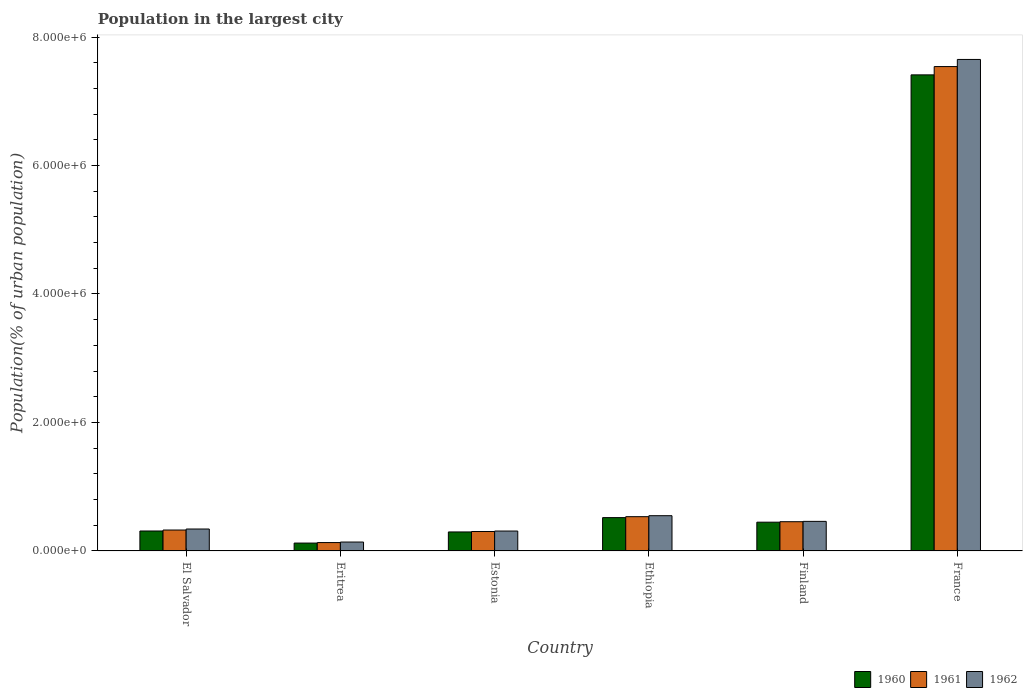How many different coloured bars are there?
Offer a terse response. 3. How many groups of bars are there?
Provide a succinct answer. 6. How many bars are there on the 3rd tick from the left?
Provide a short and direct response. 3. What is the label of the 5th group of bars from the left?
Make the answer very short. Finland. What is the population in the largest city in 1960 in Finland?
Make the answer very short. 4.48e+05. Across all countries, what is the maximum population in the largest city in 1960?
Give a very brief answer. 7.41e+06. Across all countries, what is the minimum population in the largest city in 1962?
Provide a succinct answer. 1.39e+05. In which country was the population in the largest city in 1960 maximum?
Keep it short and to the point. France. In which country was the population in the largest city in 1961 minimum?
Your response must be concise. Eritrea. What is the total population in the largest city in 1962 in the graph?
Give a very brief answer. 9.45e+06. What is the difference between the population in the largest city in 1960 in Ethiopia and that in Finland?
Your response must be concise. 7.10e+04. What is the difference between the population in the largest city in 1962 in France and the population in the largest city in 1960 in Finland?
Provide a short and direct response. 7.20e+06. What is the average population in the largest city in 1960 per country?
Provide a succinct answer. 1.52e+06. What is the difference between the population in the largest city of/in 1961 and population in the largest city of/in 1962 in El Salvador?
Your answer should be very brief. -1.58e+04. What is the ratio of the population in the largest city in 1961 in El Salvador to that in Ethiopia?
Your answer should be compact. 0.61. Is the difference between the population in the largest city in 1961 in Finland and France greater than the difference between the population in the largest city in 1962 in Finland and France?
Ensure brevity in your answer.  Yes. What is the difference between the highest and the second highest population in the largest city in 1962?
Provide a short and direct response. 8.82e+04. What is the difference between the highest and the lowest population in the largest city in 1962?
Offer a very short reply. 7.51e+06. Is the sum of the population in the largest city in 1960 in Ethiopia and France greater than the maximum population in the largest city in 1962 across all countries?
Give a very brief answer. Yes. What does the 2nd bar from the left in Estonia represents?
Give a very brief answer. 1961. What does the 1st bar from the right in Estonia represents?
Provide a succinct answer. 1962. Is it the case that in every country, the sum of the population in the largest city in 1961 and population in the largest city in 1960 is greater than the population in the largest city in 1962?
Provide a succinct answer. Yes. Are the values on the major ticks of Y-axis written in scientific E-notation?
Ensure brevity in your answer.  Yes. Does the graph contain any zero values?
Give a very brief answer. No. How are the legend labels stacked?
Provide a succinct answer. Horizontal. What is the title of the graph?
Your response must be concise. Population in the largest city. What is the label or title of the Y-axis?
Keep it short and to the point. Population(% of urban population). What is the Population(% of urban population) of 1960 in El Salvador?
Make the answer very short. 3.11e+05. What is the Population(% of urban population) of 1961 in El Salvador?
Your answer should be compact. 3.26e+05. What is the Population(% of urban population) in 1962 in El Salvador?
Offer a terse response. 3.42e+05. What is the Population(% of urban population) in 1960 in Eritrea?
Your answer should be very brief. 1.23e+05. What is the Population(% of urban population) of 1961 in Eritrea?
Keep it short and to the point. 1.31e+05. What is the Population(% of urban population) in 1962 in Eritrea?
Offer a terse response. 1.39e+05. What is the Population(% of urban population) of 1960 in Estonia?
Make the answer very short. 2.96e+05. What is the Population(% of urban population) in 1961 in Estonia?
Offer a terse response. 3.03e+05. What is the Population(% of urban population) of 1962 in Estonia?
Make the answer very short. 3.10e+05. What is the Population(% of urban population) in 1960 in Ethiopia?
Offer a terse response. 5.19e+05. What is the Population(% of urban population) in 1961 in Ethiopia?
Your response must be concise. 5.34e+05. What is the Population(% of urban population) of 1962 in Ethiopia?
Your response must be concise. 5.49e+05. What is the Population(% of urban population) in 1960 in Finland?
Ensure brevity in your answer.  4.48e+05. What is the Population(% of urban population) in 1961 in Finland?
Provide a succinct answer. 4.55e+05. What is the Population(% of urban population) in 1962 in Finland?
Provide a short and direct response. 4.61e+05. What is the Population(% of urban population) in 1960 in France?
Offer a very short reply. 7.41e+06. What is the Population(% of urban population) of 1961 in France?
Offer a very short reply. 7.54e+06. What is the Population(% of urban population) of 1962 in France?
Offer a terse response. 7.65e+06. Across all countries, what is the maximum Population(% of urban population) in 1960?
Provide a succinct answer. 7.41e+06. Across all countries, what is the maximum Population(% of urban population) of 1961?
Give a very brief answer. 7.54e+06. Across all countries, what is the maximum Population(% of urban population) in 1962?
Ensure brevity in your answer.  7.65e+06. Across all countries, what is the minimum Population(% of urban population) in 1960?
Provide a succinct answer. 1.23e+05. Across all countries, what is the minimum Population(% of urban population) of 1961?
Your answer should be very brief. 1.31e+05. Across all countries, what is the minimum Population(% of urban population) of 1962?
Provide a short and direct response. 1.39e+05. What is the total Population(% of urban population) of 1960 in the graph?
Keep it short and to the point. 9.11e+06. What is the total Population(% of urban population) of 1961 in the graph?
Your answer should be compact. 9.29e+06. What is the total Population(% of urban population) of 1962 in the graph?
Provide a succinct answer. 9.45e+06. What is the difference between the Population(% of urban population) of 1960 in El Salvador and that in Eritrea?
Your answer should be compact. 1.88e+05. What is the difference between the Population(% of urban population) in 1961 in El Salvador and that in Eritrea?
Your response must be concise. 1.95e+05. What is the difference between the Population(% of urban population) of 1962 in El Salvador and that in Eritrea?
Provide a short and direct response. 2.03e+05. What is the difference between the Population(% of urban population) of 1960 in El Salvador and that in Estonia?
Ensure brevity in your answer.  1.49e+04. What is the difference between the Population(% of urban population) in 1961 in El Salvador and that in Estonia?
Provide a succinct answer. 2.30e+04. What is the difference between the Population(% of urban population) in 1962 in El Salvador and that in Estonia?
Provide a short and direct response. 3.18e+04. What is the difference between the Population(% of urban population) of 1960 in El Salvador and that in Ethiopia?
Ensure brevity in your answer.  -2.08e+05. What is the difference between the Population(% of urban population) of 1961 in El Salvador and that in Ethiopia?
Provide a short and direct response. -2.08e+05. What is the difference between the Population(% of urban population) of 1962 in El Salvador and that in Ethiopia?
Offer a terse response. -2.07e+05. What is the difference between the Population(% of urban population) in 1960 in El Salvador and that in Finland?
Ensure brevity in your answer.  -1.37e+05. What is the difference between the Population(% of urban population) of 1961 in El Salvador and that in Finland?
Ensure brevity in your answer.  -1.29e+05. What is the difference between the Population(% of urban population) of 1962 in El Salvador and that in Finland?
Your answer should be compact. -1.19e+05. What is the difference between the Population(% of urban population) in 1960 in El Salvador and that in France?
Keep it short and to the point. -7.10e+06. What is the difference between the Population(% of urban population) in 1961 in El Salvador and that in France?
Provide a succinct answer. -7.21e+06. What is the difference between the Population(% of urban population) in 1962 in El Salvador and that in France?
Make the answer very short. -7.31e+06. What is the difference between the Population(% of urban population) of 1960 in Eritrea and that in Estonia?
Keep it short and to the point. -1.73e+05. What is the difference between the Population(% of urban population) of 1961 in Eritrea and that in Estonia?
Your answer should be very brief. -1.72e+05. What is the difference between the Population(% of urban population) of 1962 in Eritrea and that in Estonia?
Your response must be concise. -1.71e+05. What is the difference between the Population(% of urban population) in 1960 in Eritrea and that in Ethiopia?
Your response must be concise. -3.96e+05. What is the difference between the Population(% of urban population) in 1961 in Eritrea and that in Ethiopia?
Keep it short and to the point. -4.03e+05. What is the difference between the Population(% of urban population) of 1962 in Eritrea and that in Ethiopia?
Offer a very short reply. -4.10e+05. What is the difference between the Population(% of urban population) in 1960 in Eritrea and that in Finland?
Ensure brevity in your answer.  -3.25e+05. What is the difference between the Population(% of urban population) of 1961 in Eritrea and that in Finland?
Ensure brevity in your answer.  -3.25e+05. What is the difference between the Population(% of urban population) of 1962 in Eritrea and that in Finland?
Provide a succinct answer. -3.22e+05. What is the difference between the Population(% of urban population) of 1960 in Eritrea and that in France?
Your answer should be very brief. -7.29e+06. What is the difference between the Population(% of urban population) in 1961 in Eritrea and that in France?
Your response must be concise. -7.41e+06. What is the difference between the Population(% of urban population) in 1962 in Eritrea and that in France?
Provide a short and direct response. -7.51e+06. What is the difference between the Population(% of urban population) in 1960 in Estonia and that in Ethiopia?
Make the answer very short. -2.23e+05. What is the difference between the Population(% of urban population) of 1961 in Estonia and that in Ethiopia?
Provide a short and direct response. -2.31e+05. What is the difference between the Population(% of urban population) in 1962 in Estonia and that in Ethiopia?
Your answer should be compact. -2.39e+05. What is the difference between the Population(% of urban population) in 1960 in Estonia and that in Finland?
Provide a short and direct response. -1.52e+05. What is the difference between the Population(% of urban population) in 1961 in Estonia and that in Finland?
Provide a succinct answer. -1.52e+05. What is the difference between the Population(% of urban population) of 1962 in Estonia and that in Finland?
Offer a terse response. -1.51e+05. What is the difference between the Population(% of urban population) in 1960 in Estonia and that in France?
Give a very brief answer. -7.11e+06. What is the difference between the Population(% of urban population) in 1961 in Estonia and that in France?
Keep it short and to the point. -7.24e+06. What is the difference between the Population(% of urban population) in 1962 in Estonia and that in France?
Your answer should be very brief. -7.34e+06. What is the difference between the Population(% of urban population) in 1960 in Ethiopia and that in Finland?
Your response must be concise. 7.10e+04. What is the difference between the Population(% of urban population) in 1961 in Ethiopia and that in Finland?
Ensure brevity in your answer.  7.85e+04. What is the difference between the Population(% of urban population) of 1962 in Ethiopia and that in Finland?
Ensure brevity in your answer.  8.82e+04. What is the difference between the Population(% of urban population) of 1960 in Ethiopia and that in France?
Keep it short and to the point. -6.89e+06. What is the difference between the Population(% of urban population) of 1961 in Ethiopia and that in France?
Your answer should be compact. -7.01e+06. What is the difference between the Population(% of urban population) of 1962 in Ethiopia and that in France?
Your answer should be compact. -7.10e+06. What is the difference between the Population(% of urban population) in 1960 in Finland and that in France?
Offer a terse response. -6.96e+06. What is the difference between the Population(% of urban population) in 1961 in Finland and that in France?
Your answer should be compact. -7.08e+06. What is the difference between the Population(% of urban population) in 1962 in Finland and that in France?
Make the answer very short. -7.19e+06. What is the difference between the Population(% of urban population) of 1960 in El Salvador and the Population(% of urban population) of 1961 in Eritrea?
Ensure brevity in your answer.  1.80e+05. What is the difference between the Population(% of urban population) of 1960 in El Salvador and the Population(% of urban population) of 1962 in Eritrea?
Make the answer very short. 1.72e+05. What is the difference between the Population(% of urban population) in 1961 in El Salvador and the Population(% of urban population) in 1962 in Eritrea?
Ensure brevity in your answer.  1.87e+05. What is the difference between the Population(% of urban population) in 1960 in El Salvador and the Population(% of urban population) in 1961 in Estonia?
Your answer should be very brief. 8011. What is the difference between the Population(% of urban population) in 1960 in El Salvador and the Population(% of urban population) in 1962 in Estonia?
Provide a succinct answer. 942. What is the difference between the Population(% of urban population) in 1961 in El Salvador and the Population(% of urban population) in 1962 in Estonia?
Provide a succinct answer. 1.60e+04. What is the difference between the Population(% of urban population) of 1960 in El Salvador and the Population(% of urban population) of 1961 in Ethiopia?
Your answer should be very brief. -2.23e+05. What is the difference between the Population(% of urban population) of 1960 in El Salvador and the Population(% of urban population) of 1962 in Ethiopia?
Provide a succinct answer. -2.38e+05. What is the difference between the Population(% of urban population) of 1961 in El Salvador and the Population(% of urban population) of 1962 in Ethiopia?
Offer a terse response. -2.23e+05. What is the difference between the Population(% of urban population) of 1960 in El Salvador and the Population(% of urban population) of 1961 in Finland?
Provide a succinct answer. -1.44e+05. What is the difference between the Population(% of urban population) of 1960 in El Salvador and the Population(% of urban population) of 1962 in Finland?
Your response must be concise. -1.50e+05. What is the difference between the Population(% of urban population) in 1961 in El Salvador and the Population(% of urban population) in 1962 in Finland?
Keep it short and to the point. -1.35e+05. What is the difference between the Population(% of urban population) in 1960 in El Salvador and the Population(% of urban population) in 1961 in France?
Give a very brief answer. -7.23e+06. What is the difference between the Population(% of urban population) of 1960 in El Salvador and the Population(% of urban population) of 1962 in France?
Your response must be concise. -7.34e+06. What is the difference between the Population(% of urban population) of 1961 in El Salvador and the Population(% of urban population) of 1962 in France?
Make the answer very short. -7.32e+06. What is the difference between the Population(% of urban population) in 1960 in Eritrea and the Population(% of urban population) in 1961 in Estonia?
Offer a terse response. -1.80e+05. What is the difference between the Population(% of urban population) in 1960 in Eritrea and the Population(% of urban population) in 1962 in Estonia?
Your answer should be compact. -1.87e+05. What is the difference between the Population(% of urban population) in 1961 in Eritrea and the Population(% of urban population) in 1962 in Estonia?
Keep it short and to the point. -1.79e+05. What is the difference between the Population(% of urban population) in 1960 in Eritrea and the Population(% of urban population) in 1961 in Ethiopia?
Keep it short and to the point. -4.11e+05. What is the difference between the Population(% of urban population) in 1960 in Eritrea and the Population(% of urban population) in 1962 in Ethiopia?
Offer a terse response. -4.26e+05. What is the difference between the Population(% of urban population) in 1961 in Eritrea and the Population(% of urban population) in 1962 in Ethiopia?
Your response must be concise. -4.18e+05. What is the difference between the Population(% of urban population) of 1960 in Eritrea and the Population(% of urban population) of 1961 in Finland?
Provide a succinct answer. -3.32e+05. What is the difference between the Population(% of urban population) of 1960 in Eritrea and the Population(% of urban population) of 1962 in Finland?
Keep it short and to the point. -3.38e+05. What is the difference between the Population(% of urban population) in 1961 in Eritrea and the Population(% of urban population) in 1962 in Finland?
Give a very brief answer. -3.30e+05. What is the difference between the Population(% of urban population) in 1960 in Eritrea and the Population(% of urban population) in 1961 in France?
Your response must be concise. -7.42e+06. What is the difference between the Population(% of urban population) of 1960 in Eritrea and the Population(% of urban population) of 1962 in France?
Make the answer very short. -7.53e+06. What is the difference between the Population(% of urban population) in 1961 in Eritrea and the Population(% of urban population) in 1962 in France?
Your answer should be compact. -7.52e+06. What is the difference between the Population(% of urban population) in 1960 in Estonia and the Population(% of urban population) in 1961 in Ethiopia?
Your response must be concise. -2.38e+05. What is the difference between the Population(% of urban population) in 1960 in Estonia and the Population(% of urban population) in 1962 in Ethiopia?
Your response must be concise. -2.53e+05. What is the difference between the Population(% of urban population) of 1961 in Estonia and the Population(% of urban population) of 1962 in Ethiopia?
Keep it short and to the point. -2.46e+05. What is the difference between the Population(% of urban population) of 1960 in Estonia and the Population(% of urban population) of 1961 in Finland?
Your response must be concise. -1.59e+05. What is the difference between the Population(% of urban population) of 1960 in Estonia and the Population(% of urban population) of 1962 in Finland?
Provide a short and direct response. -1.65e+05. What is the difference between the Population(% of urban population) of 1961 in Estonia and the Population(% of urban population) of 1962 in Finland?
Provide a succinct answer. -1.58e+05. What is the difference between the Population(% of urban population) in 1960 in Estonia and the Population(% of urban population) in 1961 in France?
Provide a short and direct response. -7.24e+06. What is the difference between the Population(% of urban population) of 1960 in Estonia and the Population(% of urban population) of 1962 in France?
Offer a terse response. -7.35e+06. What is the difference between the Population(% of urban population) of 1961 in Estonia and the Population(% of urban population) of 1962 in France?
Your answer should be compact. -7.35e+06. What is the difference between the Population(% of urban population) of 1960 in Ethiopia and the Population(% of urban population) of 1961 in Finland?
Provide a short and direct response. 6.37e+04. What is the difference between the Population(% of urban population) of 1960 in Ethiopia and the Population(% of urban population) of 1962 in Finland?
Offer a very short reply. 5.82e+04. What is the difference between the Population(% of urban population) of 1961 in Ethiopia and the Population(% of urban population) of 1962 in Finland?
Make the answer very short. 7.30e+04. What is the difference between the Population(% of urban population) of 1960 in Ethiopia and the Population(% of urban population) of 1961 in France?
Ensure brevity in your answer.  -7.02e+06. What is the difference between the Population(% of urban population) of 1960 in Ethiopia and the Population(% of urban population) of 1962 in France?
Give a very brief answer. -7.13e+06. What is the difference between the Population(% of urban population) of 1961 in Ethiopia and the Population(% of urban population) of 1962 in France?
Keep it short and to the point. -7.12e+06. What is the difference between the Population(% of urban population) of 1960 in Finland and the Population(% of urban population) of 1961 in France?
Your answer should be very brief. -7.09e+06. What is the difference between the Population(% of urban population) in 1960 in Finland and the Population(% of urban population) in 1962 in France?
Your response must be concise. -7.20e+06. What is the difference between the Population(% of urban population) of 1961 in Finland and the Population(% of urban population) of 1962 in France?
Provide a short and direct response. -7.20e+06. What is the average Population(% of urban population) in 1960 per country?
Offer a terse response. 1.52e+06. What is the average Population(% of urban population) in 1961 per country?
Provide a short and direct response. 1.55e+06. What is the average Population(% of urban population) of 1962 per country?
Keep it short and to the point. 1.58e+06. What is the difference between the Population(% of urban population) of 1960 and Population(% of urban population) of 1961 in El Salvador?
Offer a terse response. -1.50e+04. What is the difference between the Population(% of urban population) in 1960 and Population(% of urban population) in 1962 in El Salvador?
Provide a short and direct response. -3.08e+04. What is the difference between the Population(% of urban population) of 1961 and Population(% of urban population) of 1962 in El Salvador?
Offer a very short reply. -1.58e+04. What is the difference between the Population(% of urban population) of 1960 and Population(% of urban population) of 1961 in Eritrea?
Your answer should be compact. -7673. What is the difference between the Population(% of urban population) in 1960 and Population(% of urban population) in 1962 in Eritrea?
Give a very brief answer. -1.58e+04. What is the difference between the Population(% of urban population) in 1961 and Population(% of urban population) in 1962 in Eritrea?
Offer a terse response. -8161. What is the difference between the Population(% of urban population) in 1960 and Population(% of urban population) in 1961 in Estonia?
Provide a succinct answer. -6898. What is the difference between the Population(% of urban population) of 1960 and Population(% of urban population) of 1962 in Estonia?
Give a very brief answer. -1.40e+04. What is the difference between the Population(% of urban population) of 1961 and Population(% of urban population) of 1962 in Estonia?
Give a very brief answer. -7069. What is the difference between the Population(% of urban population) in 1960 and Population(% of urban population) in 1961 in Ethiopia?
Keep it short and to the point. -1.48e+04. What is the difference between the Population(% of urban population) in 1960 and Population(% of urban population) in 1962 in Ethiopia?
Keep it short and to the point. -3.00e+04. What is the difference between the Population(% of urban population) in 1961 and Population(% of urban population) in 1962 in Ethiopia?
Make the answer very short. -1.52e+04. What is the difference between the Population(% of urban population) of 1960 and Population(% of urban population) of 1961 in Finland?
Ensure brevity in your answer.  -7296. What is the difference between the Population(% of urban population) of 1960 and Population(% of urban population) of 1962 in Finland?
Ensure brevity in your answer.  -1.28e+04. What is the difference between the Population(% of urban population) of 1961 and Population(% of urban population) of 1962 in Finland?
Your answer should be very brief. -5485. What is the difference between the Population(% of urban population) of 1960 and Population(% of urban population) of 1961 in France?
Ensure brevity in your answer.  -1.29e+05. What is the difference between the Population(% of urban population) of 1960 and Population(% of urban population) of 1962 in France?
Offer a very short reply. -2.40e+05. What is the difference between the Population(% of urban population) of 1961 and Population(% of urban population) of 1962 in France?
Keep it short and to the point. -1.11e+05. What is the ratio of the Population(% of urban population) in 1960 in El Salvador to that in Eritrea?
Make the answer very short. 2.53. What is the ratio of the Population(% of urban population) of 1961 in El Salvador to that in Eritrea?
Provide a short and direct response. 2.49. What is the ratio of the Population(% of urban population) in 1962 in El Salvador to that in Eritrea?
Keep it short and to the point. 2.46. What is the ratio of the Population(% of urban population) of 1960 in El Salvador to that in Estonia?
Offer a very short reply. 1.05. What is the ratio of the Population(% of urban population) in 1961 in El Salvador to that in Estonia?
Offer a very short reply. 1.08. What is the ratio of the Population(% of urban population) in 1962 in El Salvador to that in Estonia?
Your answer should be compact. 1.1. What is the ratio of the Population(% of urban population) in 1960 in El Salvador to that in Ethiopia?
Offer a terse response. 0.6. What is the ratio of the Population(% of urban population) of 1961 in El Salvador to that in Ethiopia?
Keep it short and to the point. 0.61. What is the ratio of the Population(% of urban population) in 1962 in El Salvador to that in Ethiopia?
Your answer should be very brief. 0.62. What is the ratio of the Population(% of urban population) of 1960 in El Salvador to that in Finland?
Give a very brief answer. 0.69. What is the ratio of the Population(% of urban population) in 1961 in El Salvador to that in Finland?
Give a very brief answer. 0.72. What is the ratio of the Population(% of urban population) of 1962 in El Salvador to that in Finland?
Provide a short and direct response. 0.74. What is the ratio of the Population(% of urban population) of 1960 in El Salvador to that in France?
Provide a short and direct response. 0.04. What is the ratio of the Population(% of urban population) in 1961 in El Salvador to that in France?
Your response must be concise. 0.04. What is the ratio of the Population(% of urban population) in 1962 in El Salvador to that in France?
Keep it short and to the point. 0.04. What is the ratio of the Population(% of urban population) in 1960 in Eritrea to that in Estonia?
Offer a terse response. 0.42. What is the ratio of the Population(% of urban population) of 1961 in Eritrea to that in Estonia?
Offer a terse response. 0.43. What is the ratio of the Population(% of urban population) of 1962 in Eritrea to that in Estonia?
Provide a succinct answer. 0.45. What is the ratio of the Population(% of urban population) of 1960 in Eritrea to that in Ethiopia?
Keep it short and to the point. 0.24. What is the ratio of the Population(% of urban population) of 1961 in Eritrea to that in Ethiopia?
Offer a terse response. 0.25. What is the ratio of the Population(% of urban population) in 1962 in Eritrea to that in Ethiopia?
Your answer should be compact. 0.25. What is the ratio of the Population(% of urban population) in 1960 in Eritrea to that in Finland?
Your answer should be compact. 0.27. What is the ratio of the Population(% of urban population) in 1961 in Eritrea to that in Finland?
Offer a very short reply. 0.29. What is the ratio of the Population(% of urban population) in 1962 in Eritrea to that in Finland?
Keep it short and to the point. 0.3. What is the ratio of the Population(% of urban population) of 1960 in Eritrea to that in France?
Offer a terse response. 0.02. What is the ratio of the Population(% of urban population) in 1961 in Eritrea to that in France?
Your answer should be compact. 0.02. What is the ratio of the Population(% of urban population) in 1962 in Eritrea to that in France?
Give a very brief answer. 0.02. What is the ratio of the Population(% of urban population) of 1960 in Estonia to that in Ethiopia?
Your answer should be compact. 0.57. What is the ratio of the Population(% of urban population) of 1961 in Estonia to that in Ethiopia?
Give a very brief answer. 0.57. What is the ratio of the Population(% of urban population) in 1962 in Estonia to that in Ethiopia?
Provide a short and direct response. 0.56. What is the ratio of the Population(% of urban population) in 1960 in Estonia to that in Finland?
Offer a very short reply. 0.66. What is the ratio of the Population(% of urban population) in 1961 in Estonia to that in Finland?
Offer a very short reply. 0.67. What is the ratio of the Population(% of urban population) of 1962 in Estonia to that in Finland?
Give a very brief answer. 0.67. What is the ratio of the Population(% of urban population) of 1960 in Estonia to that in France?
Keep it short and to the point. 0.04. What is the ratio of the Population(% of urban population) of 1961 in Estonia to that in France?
Keep it short and to the point. 0.04. What is the ratio of the Population(% of urban population) of 1962 in Estonia to that in France?
Keep it short and to the point. 0.04. What is the ratio of the Population(% of urban population) in 1960 in Ethiopia to that in Finland?
Your response must be concise. 1.16. What is the ratio of the Population(% of urban population) in 1961 in Ethiopia to that in Finland?
Make the answer very short. 1.17. What is the ratio of the Population(% of urban population) of 1962 in Ethiopia to that in Finland?
Keep it short and to the point. 1.19. What is the ratio of the Population(% of urban population) in 1960 in Ethiopia to that in France?
Your response must be concise. 0.07. What is the ratio of the Population(% of urban population) in 1961 in Ethiopia to that in France?
Your answer should be very brief. 0.07. What is the ratio of the Population(% of urban population) of 1962 in Ethiopia to that in France?
Give a very brief answer. 0.07. What is the ratio of the Population(% of urban population) of 1960 in Finland to that in France?
Your answer should be very brief. 0.06. What is the ratio of the Population(% of urban population) in 1961 in Finland to that in France?
Your response must be concise. 0.06. What is the ratio of the Population(% of urban population) in 1962 in Finland to that in France?
Ensure brevity in your answer.  0.06. What is the difference between the highest and the second highest Population(% of urban population) in 1960?
Provide a short and direct response. 6.89e+06. What is the difference between the highest and the second highest Population(% of urban population) of 1961?
Make the answer very short. 7.01e+06. What is the difference between the highest and the second highest Population(% of urban population) in 1962?
Offer a terse response. 7.10e+06. What is the difference between the highest and the lowest Population(% of urban population) in 1960?
Provide a short and direct response. 7.29e+06. What is the difference between the highest and the lowest Population(% of urban population) in 1961?
Your answer should be very brief. 7.41e+06. What is the difference between the highest and the lowest Population(% of urban population) in 1962?
Your answer should be very brief. 7.51e+06. 